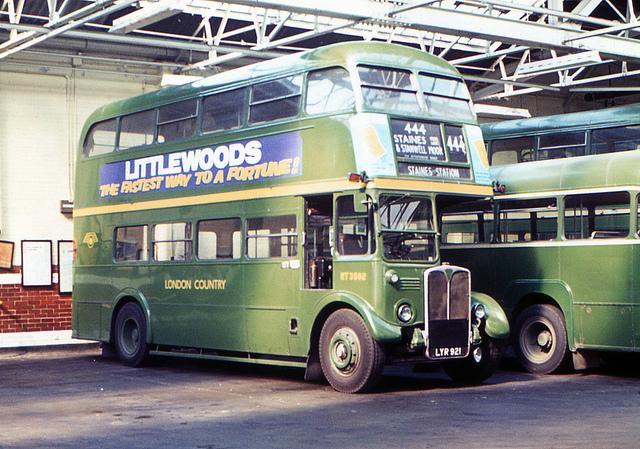Is this a double decker bus?
Short answer required. Yes. Is this in a foreign country?
Concise answer only. Yes. Where is littlewoods written on the table?
Give a very brief answer. On side of bus. 